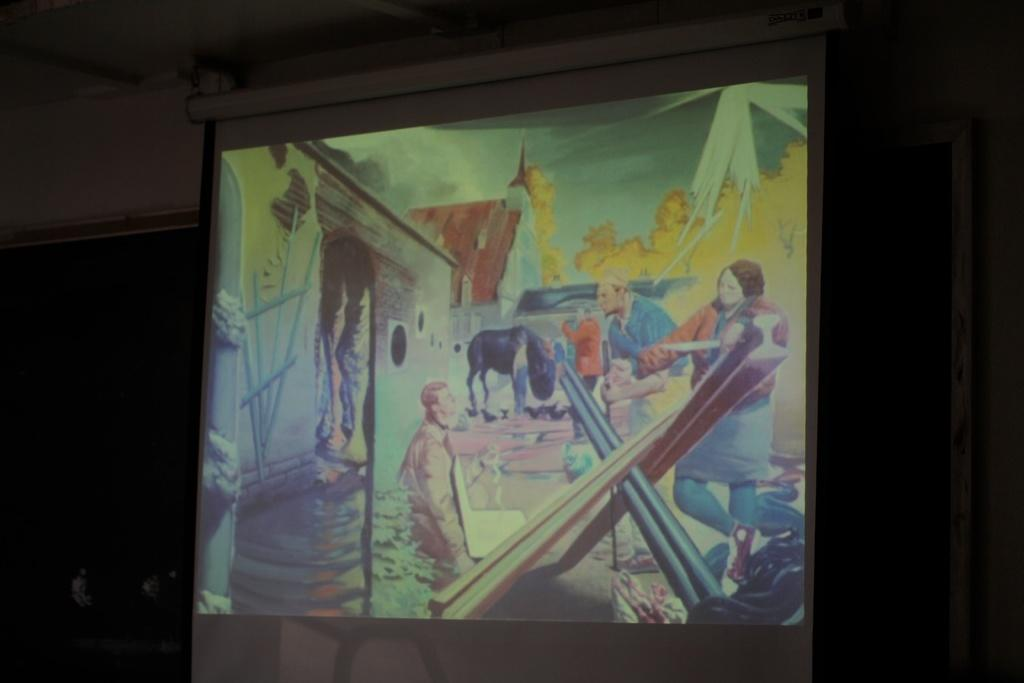What is the main object in the image? There is a projector screen in the image. What is being displayed on the projector screen? Cartoons of persons, a building, and fire are visible on the screen. Can you describe the background of the image? The background of the image is dark. What type of suit is the person wearing in the image? There is no person wearing a suit in the image; the image features a projector screen with cartoons and other visual elements. 